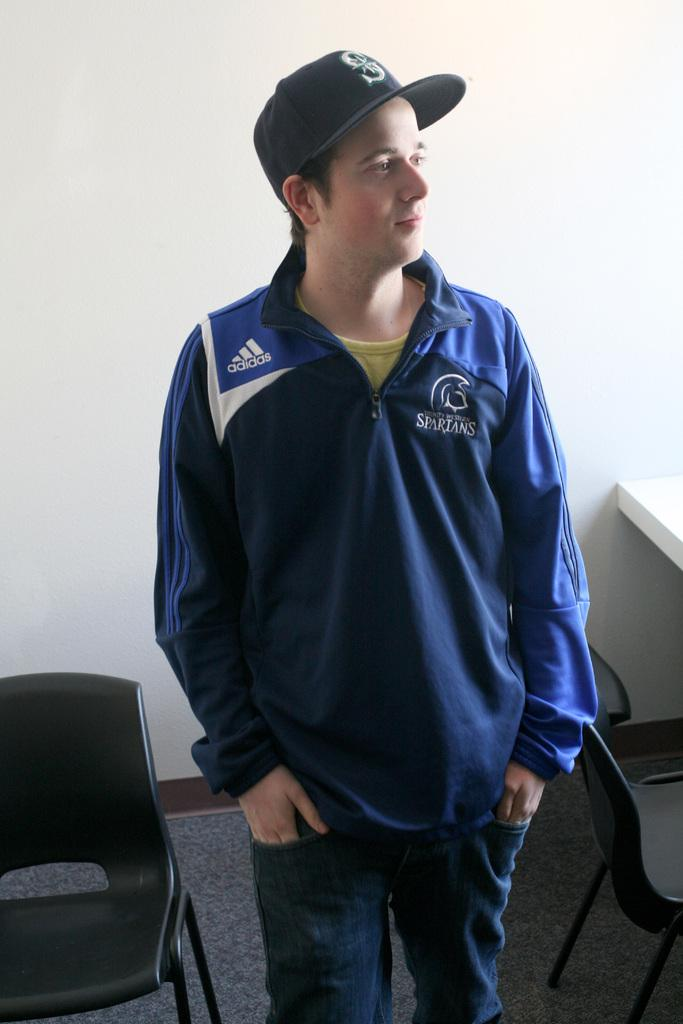Provide a one-sentence caption for the provided image. A young male wears a baseball cap and a blue Adidas pullover. 